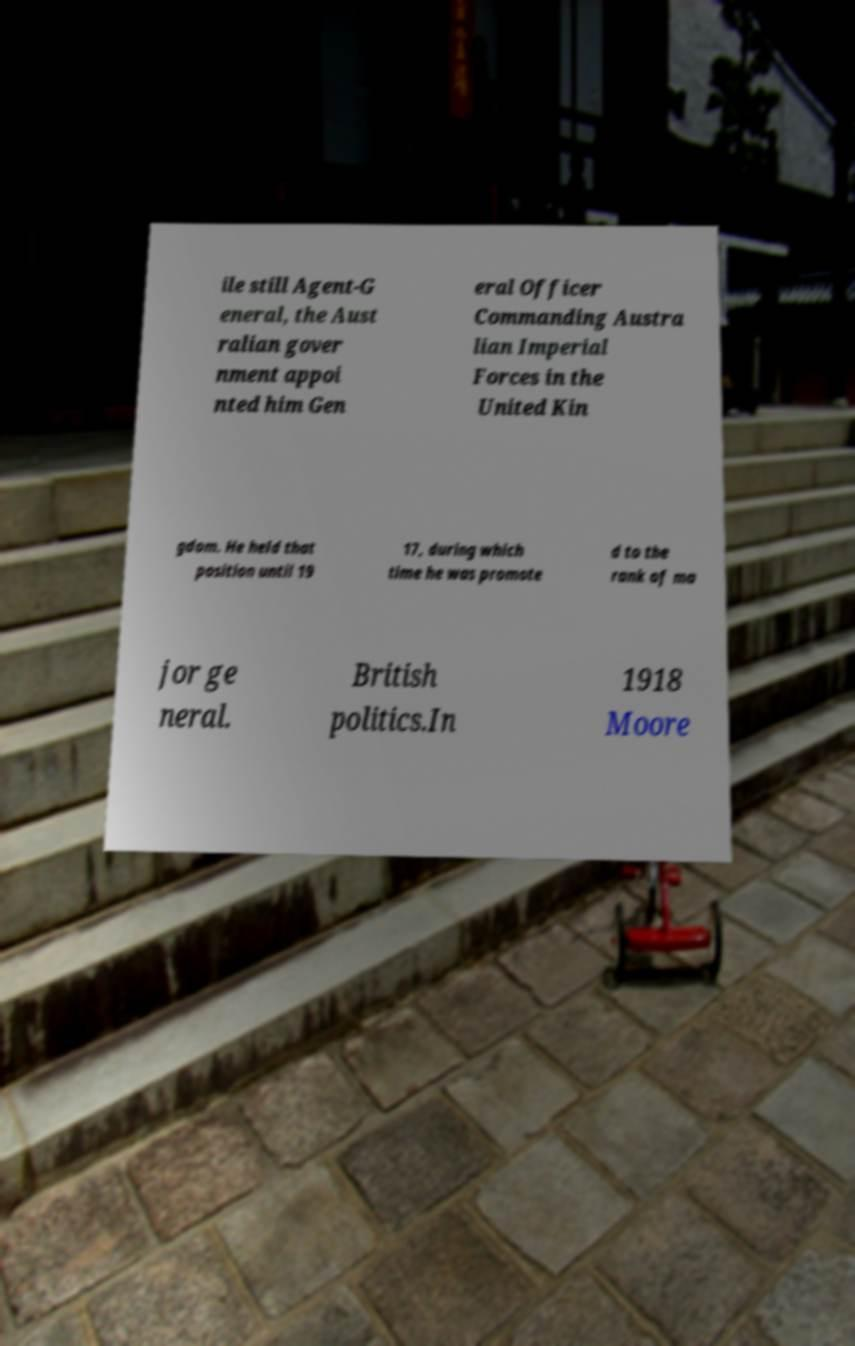Please read and relay the text visible in this image. What does it say? ile still Agent-G eneral, the Aust ralian gover nment appoi nted him Gen eral Officer Commanding Austra lian Imperial Forces in the United Kin gdom. He held that position until 19 17, during which time he was promote d to the rank of ma jor ge neral. British politics.In 1918 Moore 